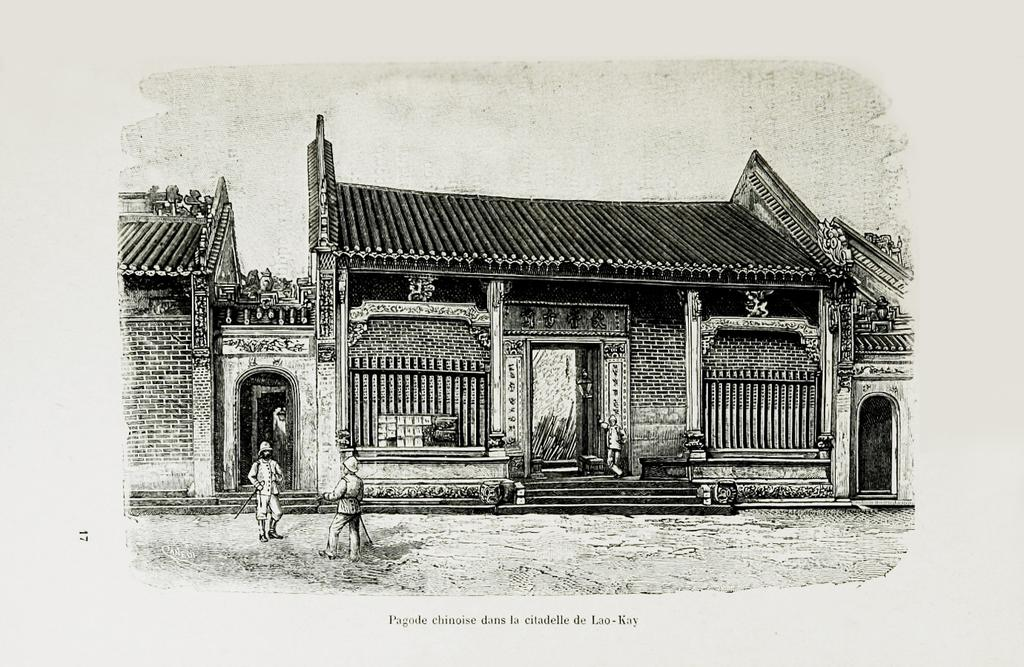What is the main subject of the image? The main subject of the image is an art of a building. Are there any other elements in the image besides the building? Yes, there are people in the image. Is there any text present in the image? Yes, there is text at the bottom of the image. What type of sail can be seen in the image? There is no sail present in the image; it features an art of a building and people. How many bowls of oatmeal are visible in the image? There are no bowls of oatmeal present in the image. 